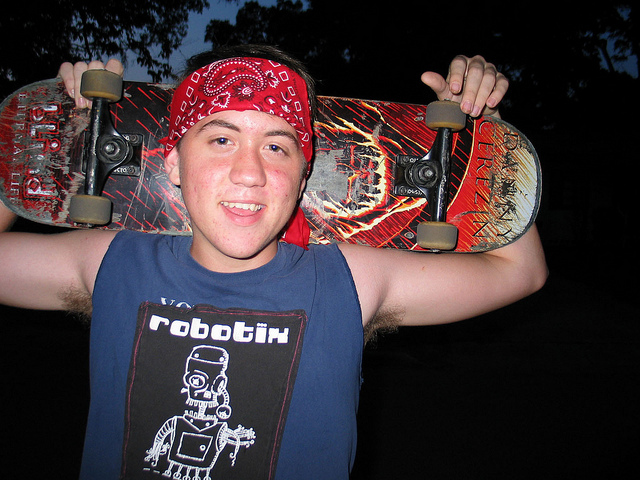Please extract the text content from this image. robotin CEREZIN 